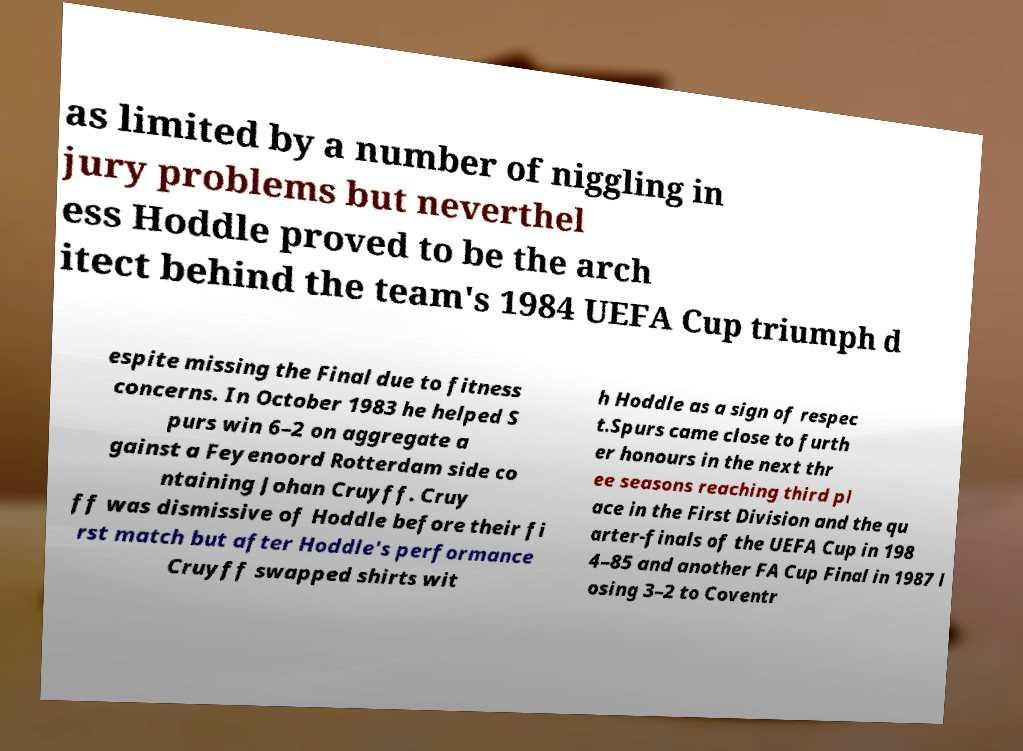Please identify and transcribe the text found in this image. as limited by a number of niggling in jury problems but neverthel ess Hoddle proved to be the arch itect behind the team's 1984 UEFA Cup triumph d espite missing the Final due to fitness concerns. In October 1983 he helped S purs win 6–2 on aggregate a gainst a Feyenoord Rotterdam side co ntaining Johan Cruyff. Cruy ff was dismissive of Hoddle before their fi rst match but after Hoddle's performance Cruyff swapped shirts wit h Hoddle as a sign of respec t.Spurs came close to furth er honours in the next thr ee seasons reaching third pl ace in the First Division and the qu arter-finals of the UEFA Cup in 198 4–85 and another FA Cup Final in 1987 l osing 3–2 to Coventr 